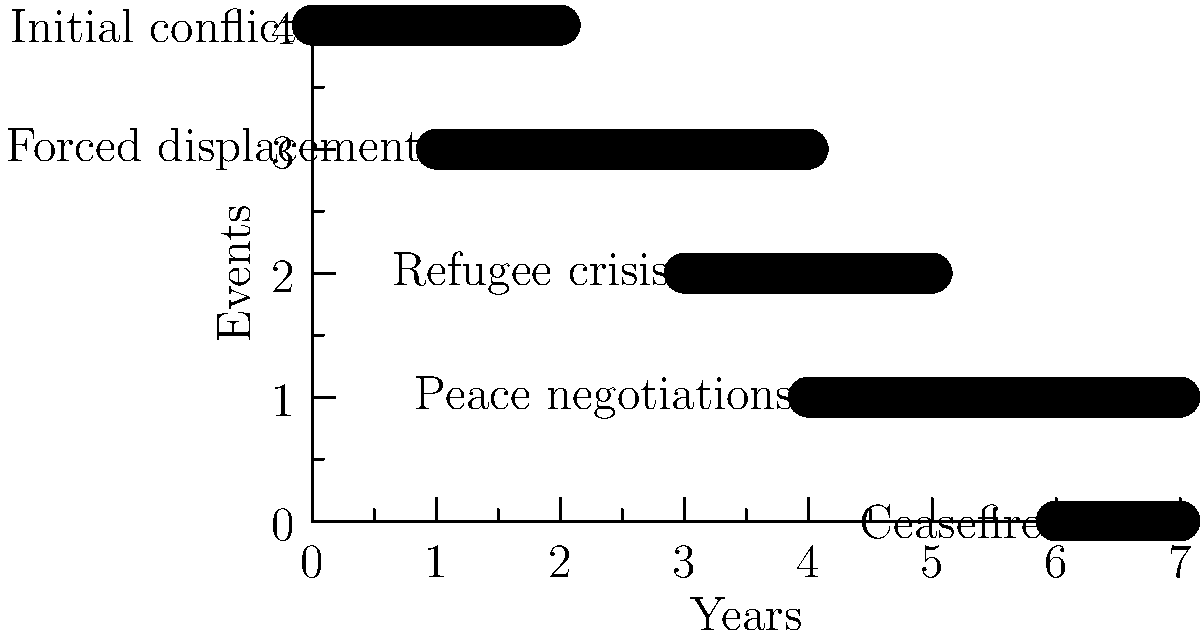Based on the timeline of conflict events shown in the horizontal bar graph, which event had the longest duration and how long did it last? To determine the event with the longest duration, we need to analyze each event's length in the graph:

1. Initial conflict: Spans 2 units
2. Forced displacement: Spans 3 units
3. Refugee crisis: Spans 2 units
4. Peace negotiations: Spans 3 units
5. Ceasefire: Spans 1 unit

We can see that two events tie for the longest duration: Forced displacement and Peace negotiations, both spanning 3 units on the timeline.

To determine how long these events lasted, we need to interpret the units on the x-axis as years. Both events span 3 years.
Answer: Forced displacement and Peace negotiations, 3 years each. 